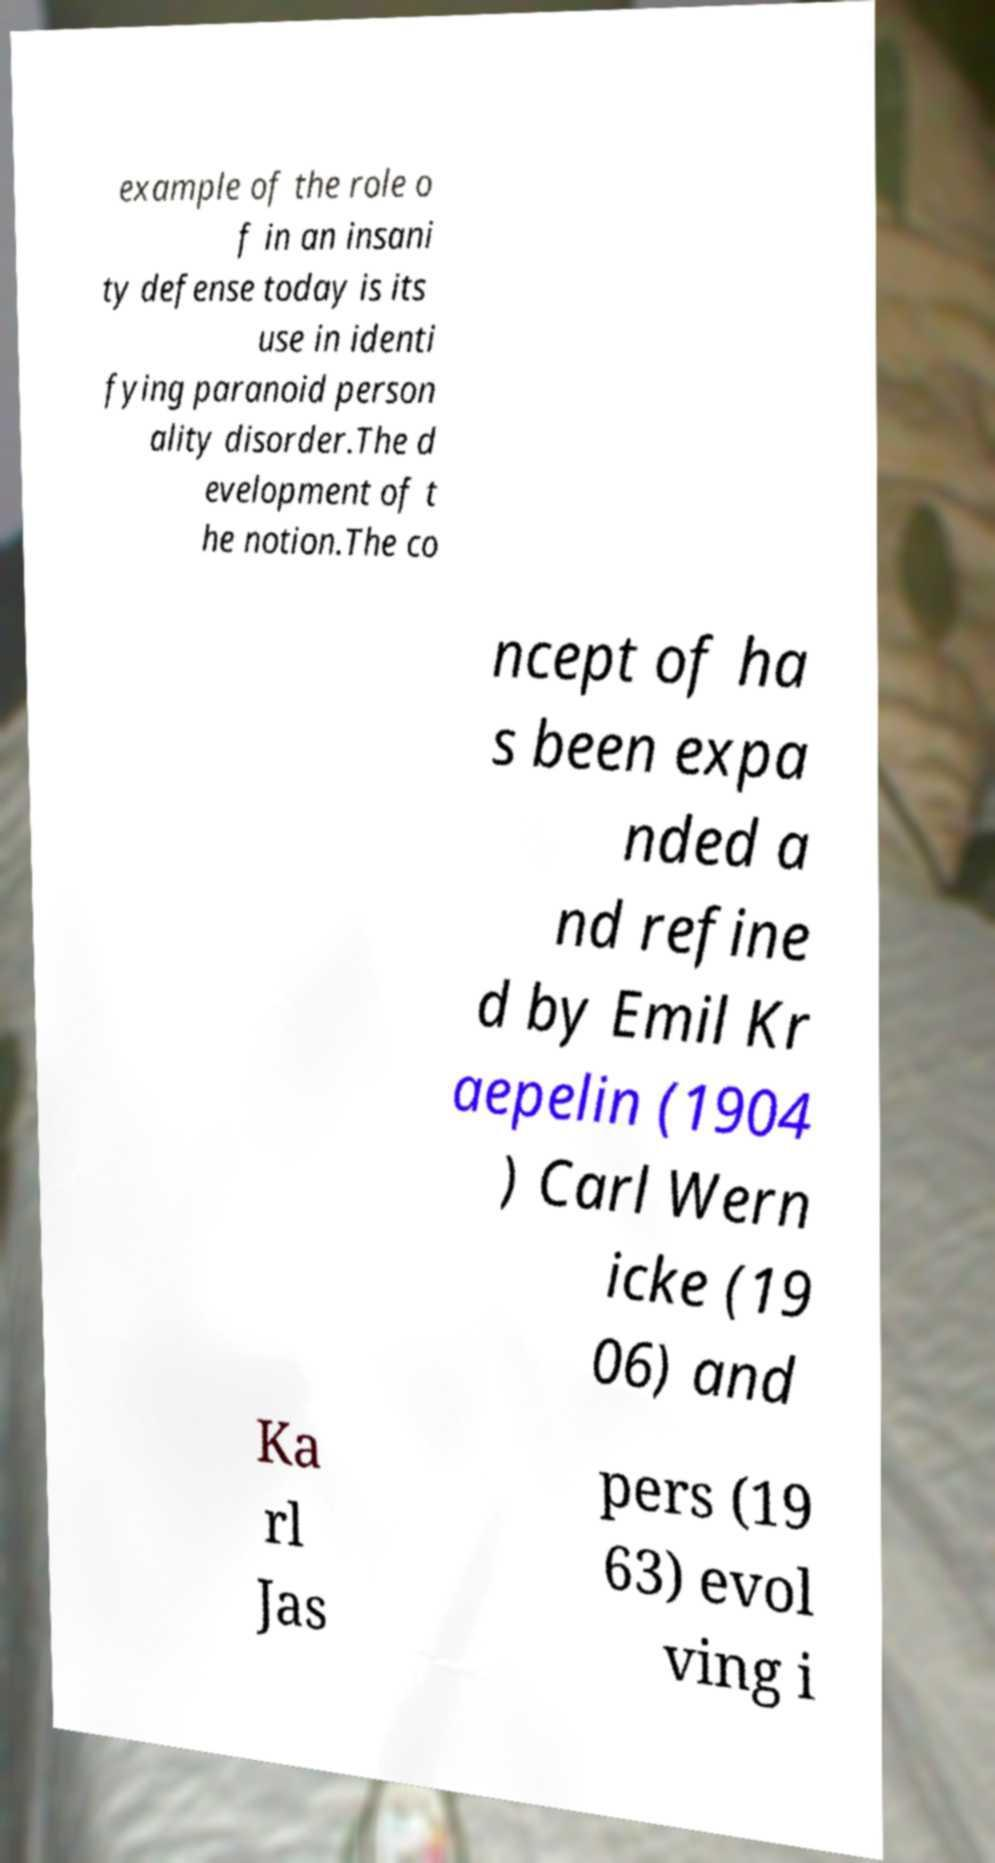Please read and relay the text visible in this image. What does it say? example of the role o f in an insani ty defense today is its use in identi fying paranoid person ality disorder.The d evelopment of t he notion.The co ncept of ha s been expa nded a nd refine d by Emil Kr aepelin (1904 ) Carl Wern icke (19 06) and Ka rl Jas pers (19 63) evol ving i 